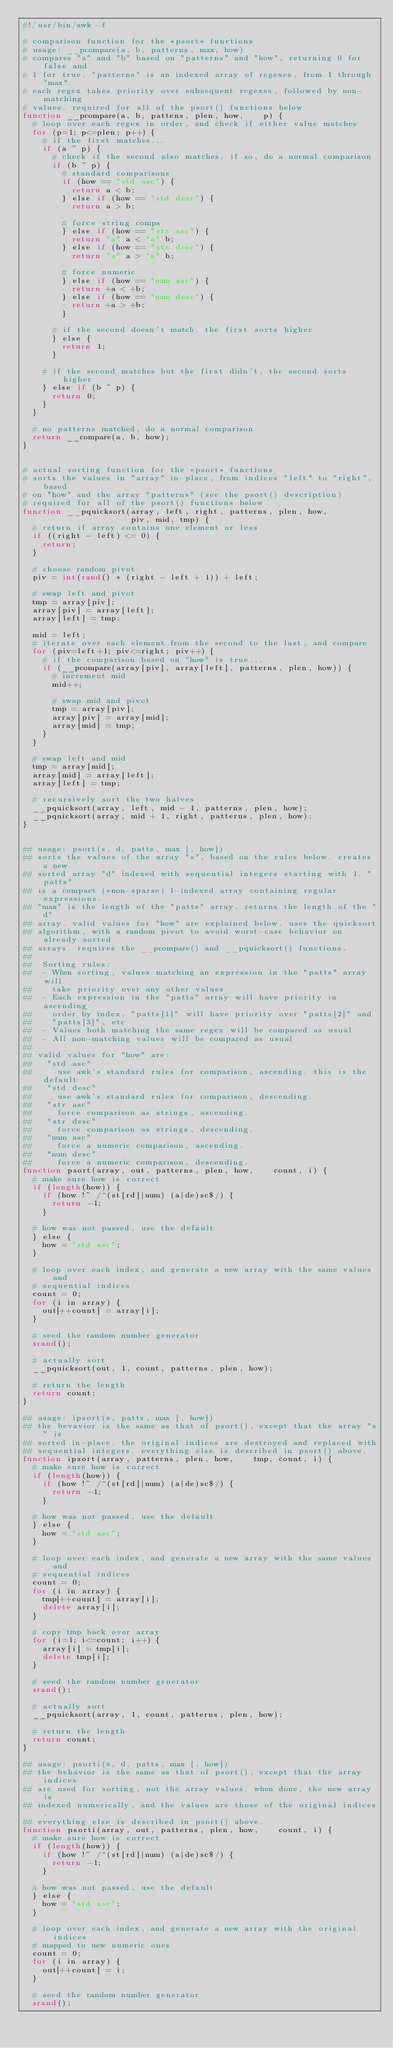Convert code to text. <code><loc_0><loc_0><loc_500><loc_500><_Awk_>#!/usr/bin/awk -f

# comparison function for the *psort* functions
# usage: __pcompare(a, b, patterns, max, how)
# compares "a" and "b" based on "patterns" and "how", returning 0 for false and
# 1 for true. "patterns" is an indexed array of regexes, from 1 through "max".
# each regex takes priority over subsequent regexes, followed by non-matching
# values. required for all of the psort() functions below
function __pcompare(a, b, pattens, plen, how,    p) {
  # loop over each regex in order, and check if either value matches
  for (p=1; p<=plen; p++) {
    # if the first matches...
    if (a ~ p) {
      # check if the second also matches. if so, do a normal comparison
      if (b ~ p) {
        # standard comparisons
        if (how == "std asc") {
          return a < b;
        } else if (how == "std desc") {
          return a > b;

        # force string comps
        } else if (how == "str asc") {
          return "a" a < "a" b;
        } else if (how == "str desc") {
          return "a" a > "a" b;

        # force numeric
        } else if (how == "num asc") {
          return +a < +b;
        } else if (how == "num desc") {
          return +a > +b;
        }

      # if the second doesn't match, the first sorts higher
      } else {
        return 1;
      }

    # if the second matches but the first didn't, the second sorts higher
    } else if (b ~ p) {
      return 0;
    }
  }

  # no patterns matched, do a normal comparison
  return __compare(a, b, how);
}


# actual sorting function for the *psort* functions
# sorts the values in "array" in-place, from indices "left" to "right", based
# on "how" and the array "patterns" (see the psort() description)
# required for all of the psort() functions below
function __pquicksort(array, left, right, patterns, plen, how,
                      piv, mid, tmp) {
  # return if array contains one element or less
  if ((right - left) <= 0) {
    return;
  }

  # choose random pivot
  piv = int(rand() * (right - left + 1)) + left;

  # swap left and pivot
  tmp = array[piv];
  array[piv] = array[left];
  array[left] = tmp;
  
  mid = left;
  # iterate over each element from the second to the last, and compare
  for (piv=left+1; piv<=right; piv++) {
    # if the comparison based on "how" is true...
    if (__pcompare(array[piv], array[left], patterns, plen, how)) {
      # increment mid
      mid++;

      # swap mid and pivot
      tmp = array[piv];
      array[piv] = array[mid];
      array[mid] = tmp;
    }
  }

  # swap left and mid
  tmp = array[mid];
  array[mid] = array[left];
  array[left] = tmp;
  
  # recursively sort the two halves
  __pquicksort(array, left, mid - 1, patterns, plen, how);
  __pquicksort(array, mid + 1, right, patterns, plen, how);
}


## usage: psort(s, d, patts, max [, how])
## sorts the values of the array "s", based on the rules below. creates a new
## sorted array "d" indexed with sequential integers starting with 1. "patts"
## is a compact (*non-sparse) 1-indexed array containing regular expressions.
## "max" is the length of the "patts" array. returns the length of the "d"
## array. valid values for "how" are explained below. uses the quicksort
## algorithm, with a random pivot to avoid worst-case behavior on already sorted
## arrays. requires the __pcompare() and __pquicksort() functions.
##
##  Sorting rules:
##  - When sorting, values matching an expression in the "patts" array will
##    take priority over any other values
##  - Each expression in the "patts" array will have priority in ascending
##    order by index. "patts[1]" will have priority over "patts[2]" and
##    "patts[3]", etc
##  - Values both matching the same regex will be compared as usual
##  - All non-matching values will be compared as usual
##
## valid values for "how" are:
##   "std asc"
##     use awk's standard rules for comparison, ascending. this is the default
##   "std desc"
##     use awk's standard rules for comparison, descending.
##   "str asc"
##     force comparison as strings, ascending.
##   "str desc"
##     force comparison as strings, descending.
##   "num asc"
##     force a numeric comparison, ascending.
##   "num desc"
##     force a numeric comparison, descending.
function psort(array, out, patterns, plen, how,    count, i) {
  # make sure how is correct
  if (length(how)) {
    if (how !~ /^(st[rd]|num) (a|de)sc$/) {
      return -1;
    }

  # how was not passed, use the default
  } else {
    how = "std asc";
  }
  
  # loop over each index, and generate a new array with the same values and
  # sequential indices
  count = 0;
  for (i in array) {
    out[++count] = array[i];
  }

  # seed the random number generator
  srand();

  # actually sort
  __pquicksort(out, 1, count, patterns, plen, how);

  # return the length
  return count;
}

## usage: ipsort(s, patts, max [, how])
## the bevavior is the same as that of psort(), except that the array "s" is
## sorted in-place. the original indices are destroyed and replaced with
## sequential integers. everything else is described in psort() above.
function ipsort(array, patterns, plen, how,    tmp, count, i) {
  # make sure how is correct
  if (length(how)) {
    if (how !~ /^(st[rd]|num) (a|de)sc$/) {
      return -1;
    }

  # how was not passed, use the default
  } else {
    how = "std asc";
  }
  
  # loop over each index, and generate a new array with the same values and
  # sequential indices
  count = 0;
  for (i in array) {
    tmp[++count] = array[i];
    delete array[i];
  }

  # copy tmp back over array
  for (i=1; i<=count; i++) {
    array[i] = tmp[i];
    delete tmp[i];
  }

  # seed the random number generator
  srand();

  # actually sort
  __pquicksort(array, 1, count, patterns, plen, how);

  # return the length
  return count;
}

## usage: psorti(s, d, patts, max [, how])
## the behavior is the same as that of psort(), except that the array indices
## are used for sorting, not the array values. when done, the new array is
## indexed numerically, and the values are those of the original indices.
## everything else is described in psort() above.
function psorti(array, out, patterns, plen, how,    count, i) {
  # make sure how is correct
  if (length(how)) {
    if (how !~ /^(st[rd]|num) (a|de)sc$/) {
      return -1;
    }

  # how was not passed, use the default
  } else {
    how = "std asc";
  }

  # loop over each index, and generate a new array with the original indices
  # mapped to new numeric ones
  count = 0;
  for (i in array) {
    out[++count] = i;
  }

  # seed the random number generator
  srand();
</code> 